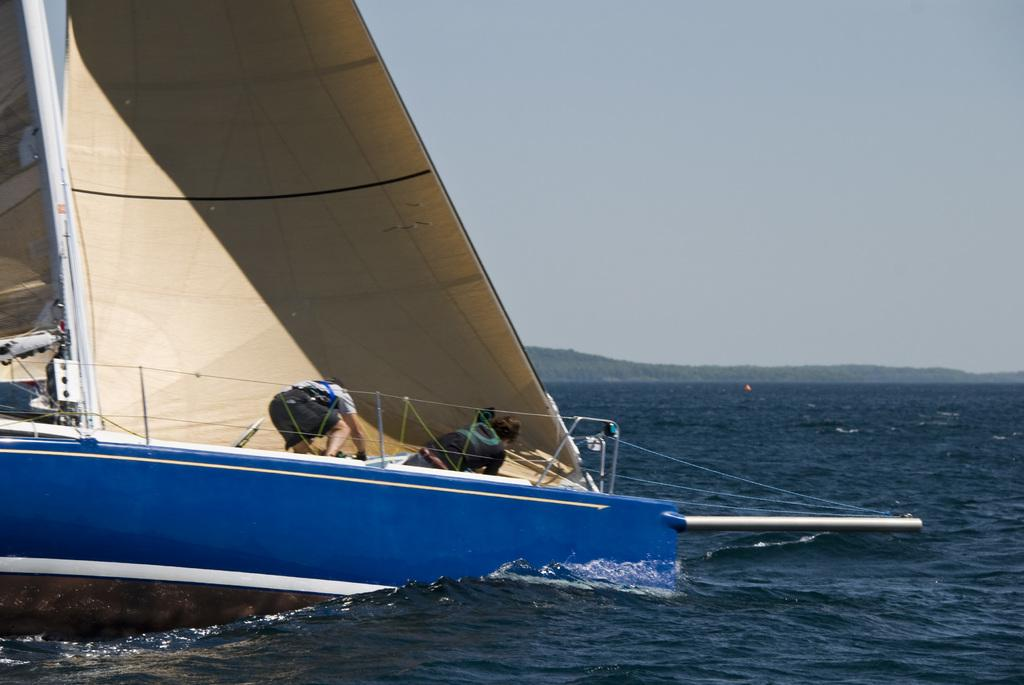How many people are in the image? There are two people in the image. What are the people doing in the image? The people are on a boat. What else can be seen on the boat besides the people? There are objects visible on the boat. Where is the boat located in the image? The boat is on water. What is visible in the background of the image? The sky is visible in the image. How many screws are visible on the boat in the image? There is no mention of screws in the image, so it is impossible to determine the number of screws visible on the boat. 